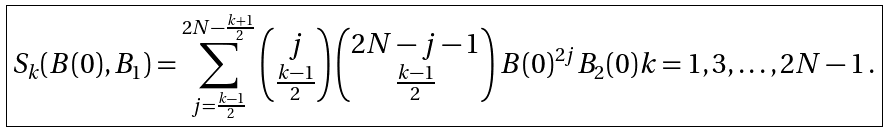Convert formula to latex. <formula><loc_0><loc_0><loc_500><loc_500>\boxed { S _ { k } ( B ( 0 ) , B _ { 1 } ) = \sum _ { j = \frac { k - 1 } 2 } ^ { 2 N - \frac { k + 1 } 2 } \begin{pmatrix} j \\ \frac { k - 1 } 2 \end{pmatrix} \begin{pmatrix} 2 N - j - 1 \\ \frac { k - 1 } 2 \end{pmatrix} B ( 0 ) ^ { 2 j } B _ { 2 } ( 0 ) k = 1 , 3 , \dots , 2 N - 1 \, . }</formula> 